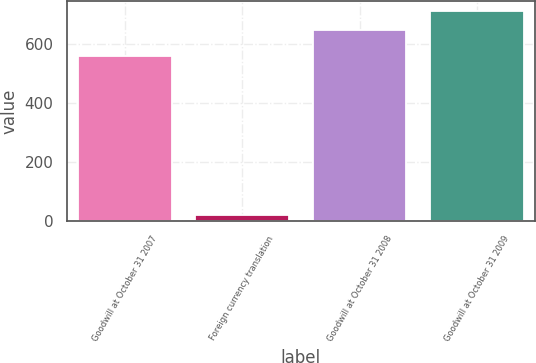<chart> <loc_0><loc_0><loc_500><loc_500><bar_chart><fcel>Goodwill at October 31 2007<fcel>Foreign currency translation<fcel>Goodwill at October 31 2008<fcel>Goodwill at October 31 2009<nl><fcel>558<fcel>21<fcel>646<fcel>709.4<nl></chart> 